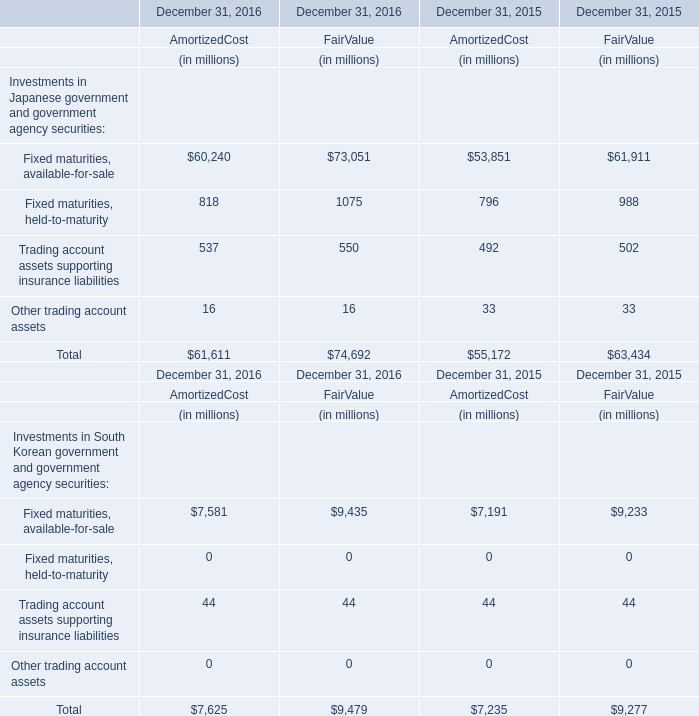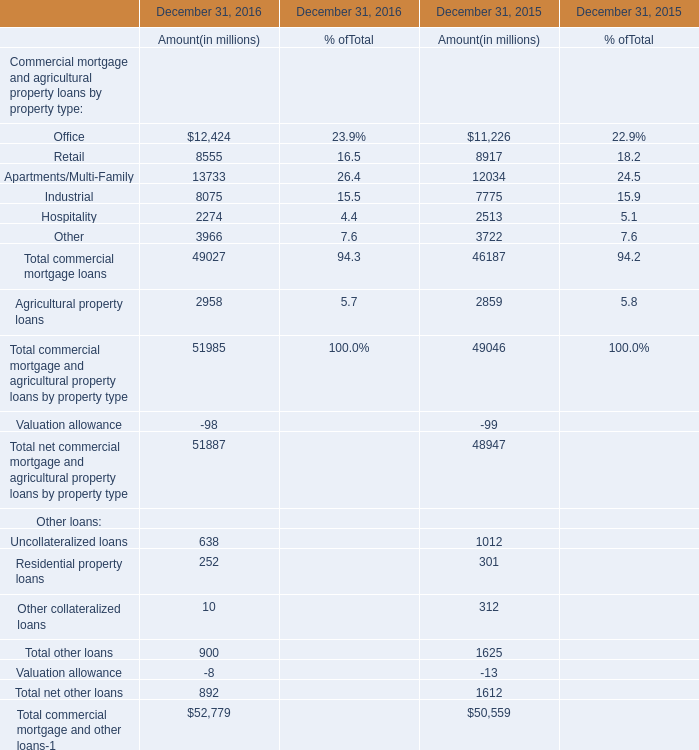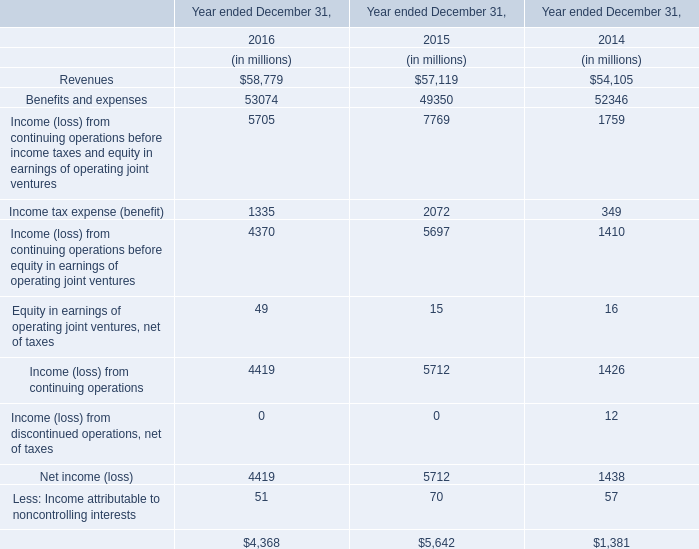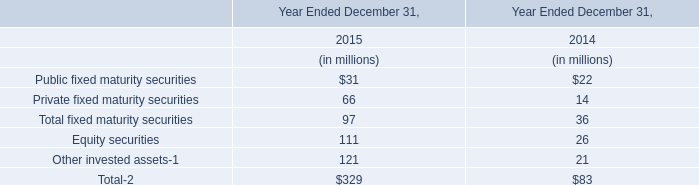What is the percentage of all Industrial that are positive to the total amount, in amount? 
Computations: (8075 / (8075 + 7775))
Answer: 0.50946. 